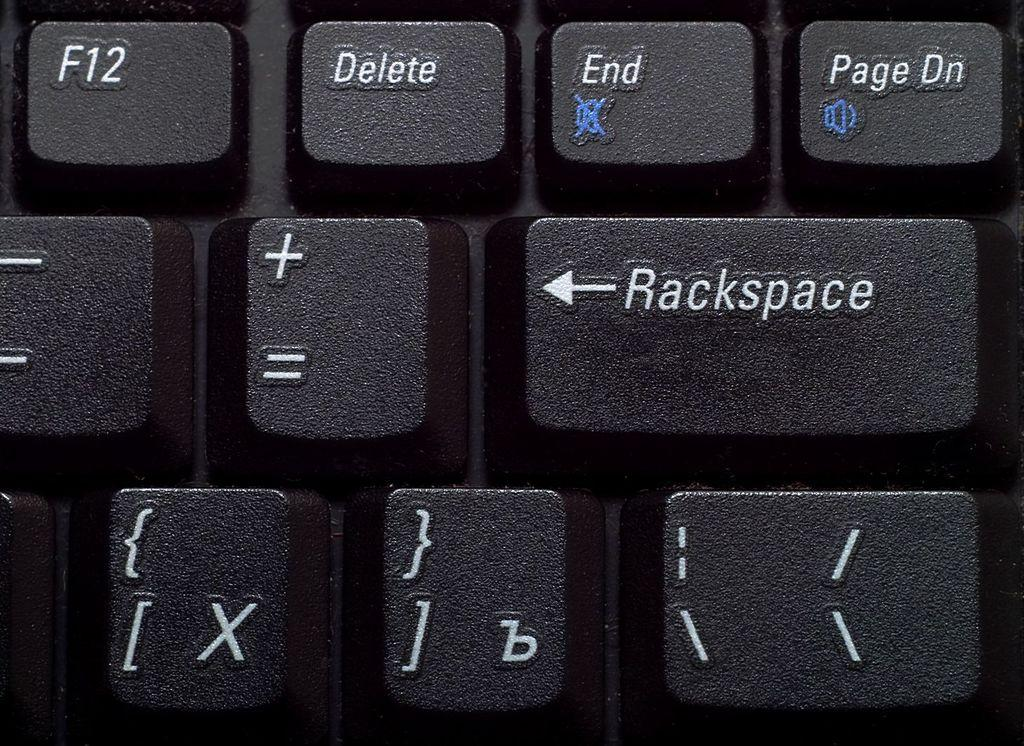What objects are present in the image? There are keys in the image. What distinguishing features do the keys have? The keys have words and symbols on them. What type of cloth is draped over the keys in the image? There is no cloth present in the image; it only shows keys with words and symbols on them. 